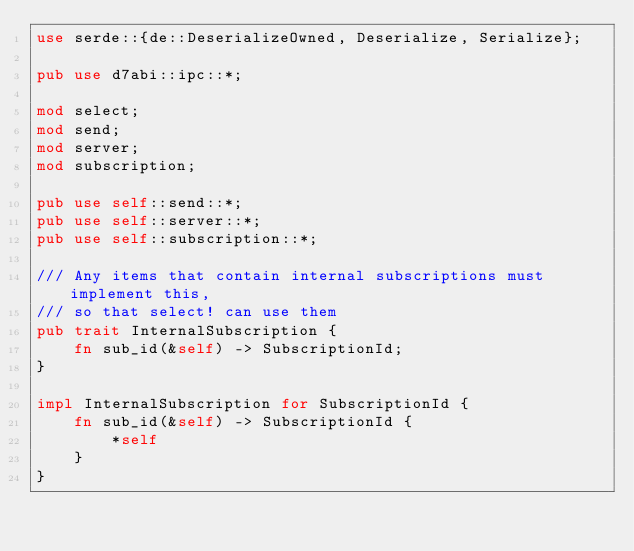<code> <loc_0><loc_0><loc_500><loc_500><_Rust_>use serde::{de::DeserializeOwned, Deserialize, Serialize};

pub use d7abi::ipc::*;

mod select;
mod send;
mod server;
mod subscription;

pub use self::send::*;
pub use self::server::*;
pub use self::subscription::*;

/// Any items that contain internal subscriptions must implement this,
/// so that select! can use them
pub trait InternalSubscription {
    fn sub_id(&self) -> SubscriptionId;
}

impl InternalSubscription for SubscriptionId {
    fn sub_id(&self) -> SubscriptionId {
        *self
    }
}
</code> 